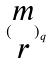<formula> <loc_0><loc_0><loc_500><loc_500>( \begin{matrix} m \\ r \end{matrix} ) _ { q }</formula> 